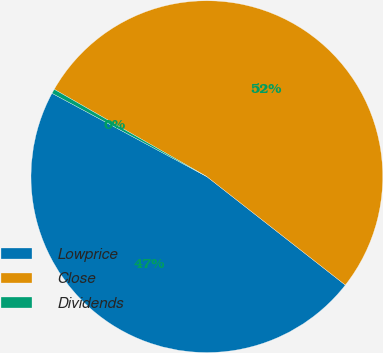<chart> <loc_0><loc_0><loc_500><loc_500><pie_chart><fcel>Lowprice<fcel>Close<fcel>Dividends<nl><fcel>47.29%<fcel>52.3%<fcel>0.41%<nl></chart> 